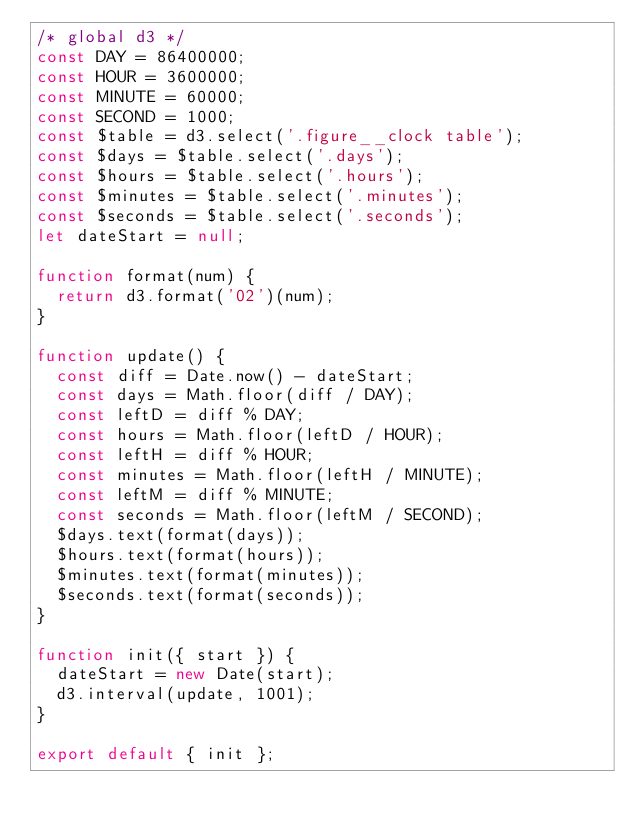Convert code to text. <code><loc_0><loc_0><loc_500><loc_500><_JavaScript_>/* global d3 */
const DAY = 86400000;
const HOUR = 3600000;
const MINUTE = 60000;
const SECOND = 1000;
const $table = d3.select('.figure__clock table');
const $days = $table.select('.days');
const $hours = $table.select('.hours');
const $minutes = $table.select('.minutes');
const $seconds = $table.select('.seconds');
let dateStart = null;

function format(num) {
  return d3.format('02')(num);
}

function update() {
  const diff = Date.now() - dateStart;
  const days = Math.floor(diff / DAY);
  const leftD = diff % DAY;
  const hours = Math.floor(leftD / HOUR);
  const leftH = diff % HOUR;
  const minutes = Math.floor(leftH / MINUTE);
  const leftM = diff % MINUTE;
  const seconds = Math.floor(leftM / SECOND);
  $days.text(format(days));
  $hours.text(format(hours));
  $minutes.text(format(minutes));
  $seconds.text(format(seconds));
}

function init({ start }) {
  dateStart = new Date(start);
  d3.interval(update, 1001);
}

export default { init };
</code> 